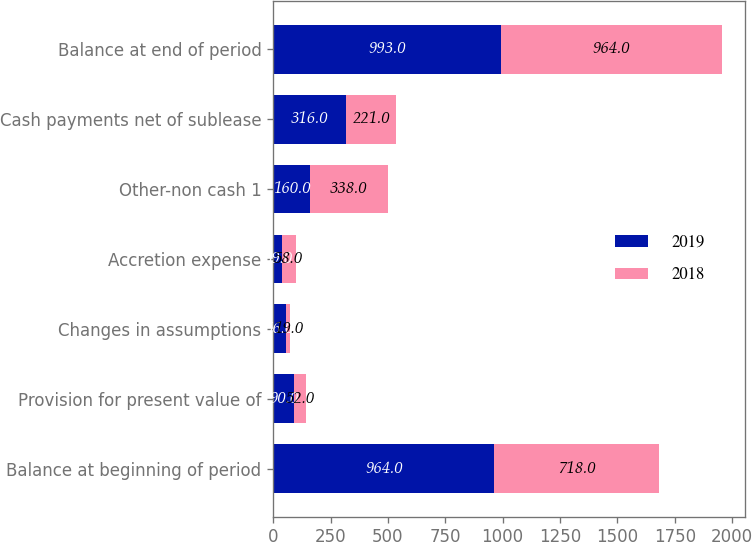<chart> <loc_0><loc_0><loc_500><loc_500><stacked_bar_chart><ecel><fcel>Balance at beginning of period<fcel>Provision for present value of<fcel>Changes in assumptions<fcel>Accretion expense<fcel>Other-non cash 1<fcel>Cash payments net of sublease<fcel>Balance at end of period<nl><fcel>2019<fcel>964<fcel>90<fcel>56<fcel>39<fcel>160<fcel>316<fcel>993<nl><fcel>2018<fcel>718<fcel>52<fcel>19<fcel>58<fcel>338<fcel>221<fcel>964<nl></chart> 